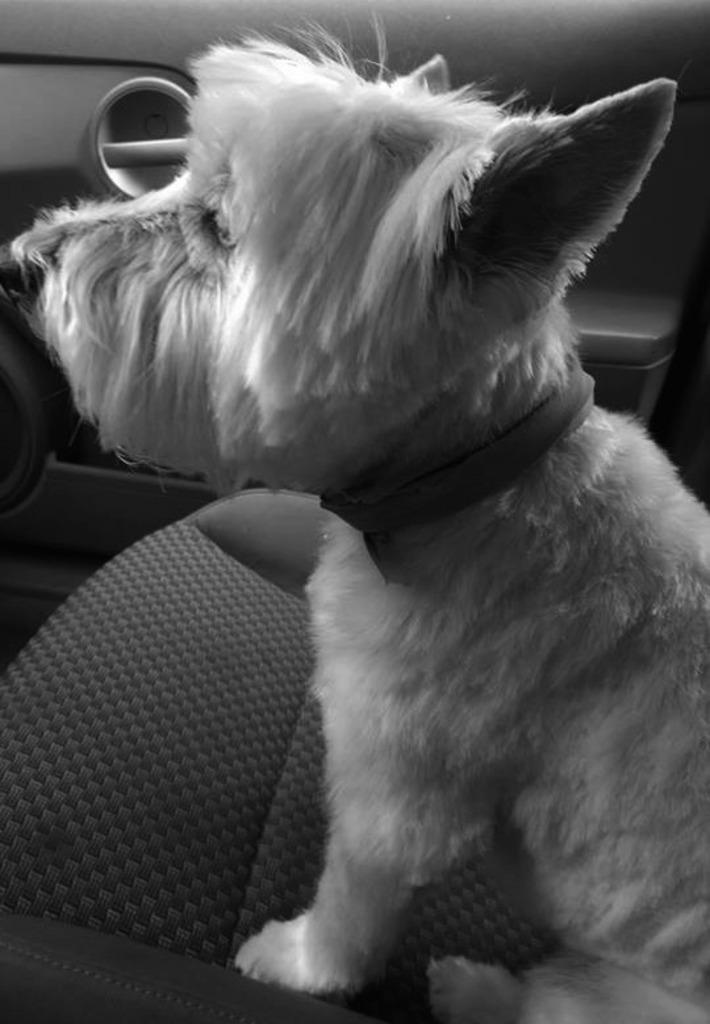What type of animal is present in the image? There is a dog in the image. Where is the dog located in the image? The dog is sitting in a car. What type of nut is the dog holding in its paw in the image? There is no nut present in the image; the dog is simply sitting in a car. 